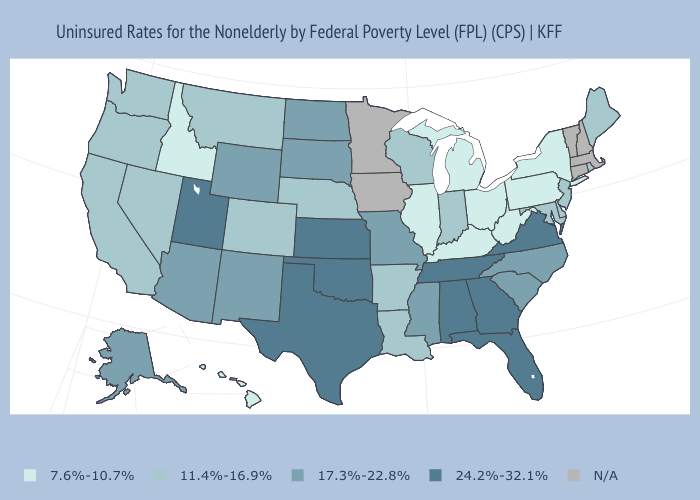Which states have the lowest value in the West?
Be succinct. Hawaii, Idaho. What is the highest value in states that border Pennsylvania?
Write a very short answer. 11.4%-16.9%. Which states hav the highest value in the MidWest?
Answer briefly. Kansas. Does the first symbol in the legend represent the smallest category?
Quick response, please. Yes. What is the value of Illinois?
Write a very short answer. 7.6%-10.7%. Name the states that have a value in the range 17.3%-22.8%?
Concise answer only. Alaska, Arizona, Mississippi, Missouri, New Mexico, North Carolina, North Dakota, South Carolina, South Dakota, Wyoming. Does the first symbol in the legend represent the smallest category?
Answer briefly. Yes. Does Oklahoma have the highest value in the South?
Keep it brief. Yes. Name the states that have a value in the range 17.3%-22.8%?
Answer briefly. Alaska, Arizona, Mississippi, Missouri, New Mexico, North Carolina, North Dakota, South Carolina, South Dakota, Wyoming. Name the states that have a value in the range 11.4%-16.9%?
Keep it brief. Arkansas, California, Colorado, Delaware, Indiana, Louisiana, Maine, Maryland, Montana, Nebraska, Nevada, New Jersey, Oregon, Rhode Island, Washington, Wisconsin. What is the lowest value in the West?
Give a very brief answer. 7.6%-10.7%. Does the map have missing data?
Answer briefly. Yes. Among the states that border Texas , does Oklahoma have the lowest value?
Keep it brief. No. 